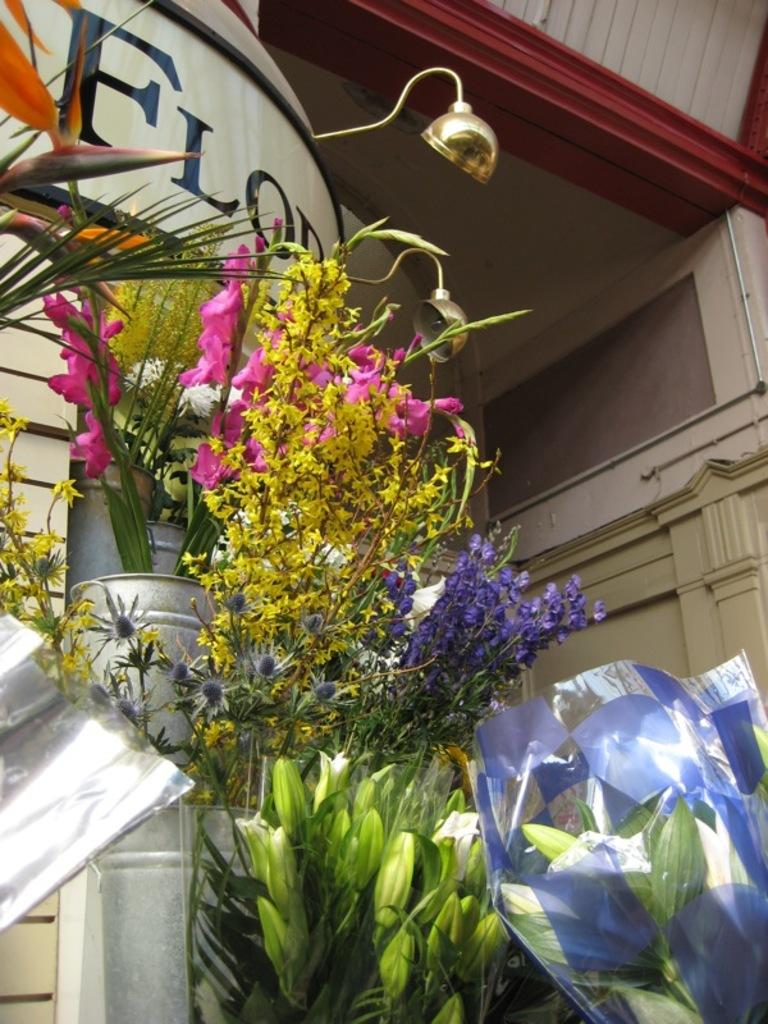What can be seen in the foreground of the image? There are flower bouquets in the foreground of the image. What is located at the top of the image? There appears to be a lamp at the top of the image. What type of scientific experiment is being conducted with the flower bouquets in the image? There is no indication of a scientific experiment in the image; it simply features flower bouquets in the foreground. What color thread is used to hold the flower bouquets together in the image? There is no visible thread holding the flower bouquets together in the image. 